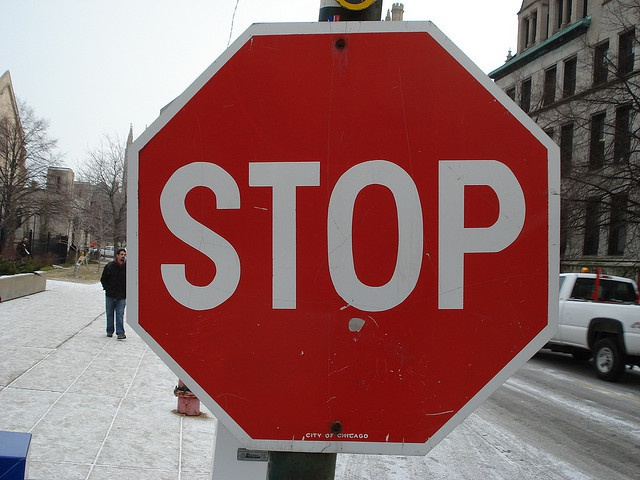Describe the objects in this image and their specific colors. I can see stop sign in lightgray, maroon, darkgray, and brown tones, truck in lightgray, black, darkgray, gray, and maroon tones, people in lightgray, black, darkblue, blue, and gray tones, fire hydrant in lightgray, brown, maroon, and black tones, and people in lightgray, black, maroon, gray, and darkgray tones in this image. 